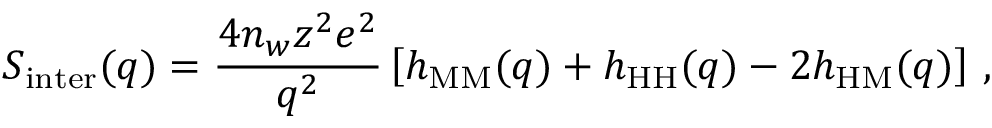<formula> <loc_0><loc_0><loc_500><loc_500>S _ { i n t e r } ( q ) = \frac { 4 n _ { w } z ^ { 2 } e ^ { 2 } } { q ^ { 2 } } \left [ h _ { M M } ( q ) + h _ { H H } ( q ) - 2 h _ { H M } ( q ) \right ] \, ,</formula> 